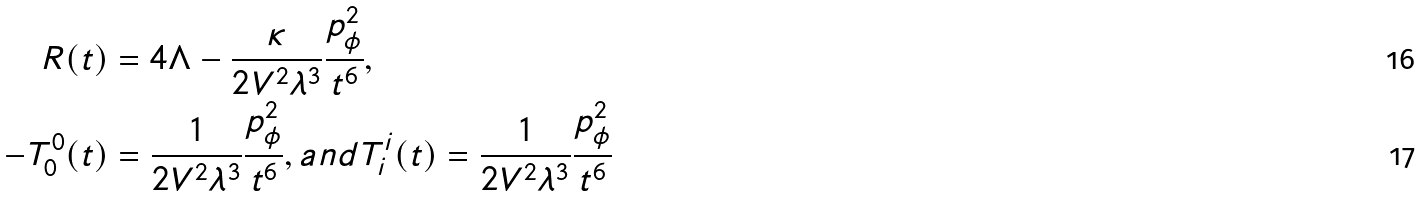Convert formula to latex. <formula><loc_0><loc_0><loc_500><loc_500>R ( t ) & = 4 \Lambda - \frac { \kappa } { 2 V ^ { 2 } \lambda ^ { 3 } } \frac { p _ { \phi } ^ { 2 } } { t ^ { 6 } } , \\ - T ^ { 0 } _ { 0 } ( t ) & = \frac { 1 } { 2 V ^ { 2 } \lambda ^ { 3 } } \frac { p _ { \phi } ^ { 2 } } { t ^ { 6 } } , a n d T ^ { i } _ { i } ( t ) = \frac { 1 } { 2 V ^ { 2 } \lambda ^ { 3 } } \frac { p _ { \phi } ^ { 2 } } { t ^ { 6 } }</formula> 